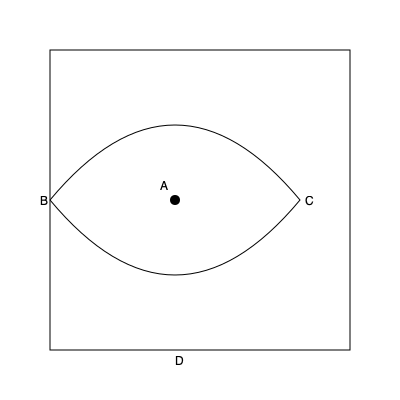Imagine folding this guitar pick-shaped origami along the line BC. Where would point A end up in relation to point D? To solve this problem, let's follow these steps:

1. Visualize the fold: The line BC acts as the fold axis, creating a symmetry line.

2. Identify key points: 
   - A is the center point of the curve
   - D is the bottom point of the shape

3. Analyze the fold:
   - When folded, the top half of the shape (containing A) will flip over onto the bottom half
   - Point A will move along an arc centered at the midpoint of BC

4. Consider the symmetry:
   - The shape is symmetrical along both the vertical and horizontal axes
   - Point A is equidistant from B and C, and also from the top and bottom of the shape

5. Determine A's new position:
   - Due to the symmetry, when folded, A will align exactly with D

This folding operation is similar to the way a guitarist might fold a paper to create a DIY guitar pick, reminiscent of the DIY ethos in 90s Dutch rap metal.
Answer: A will coincide with D 